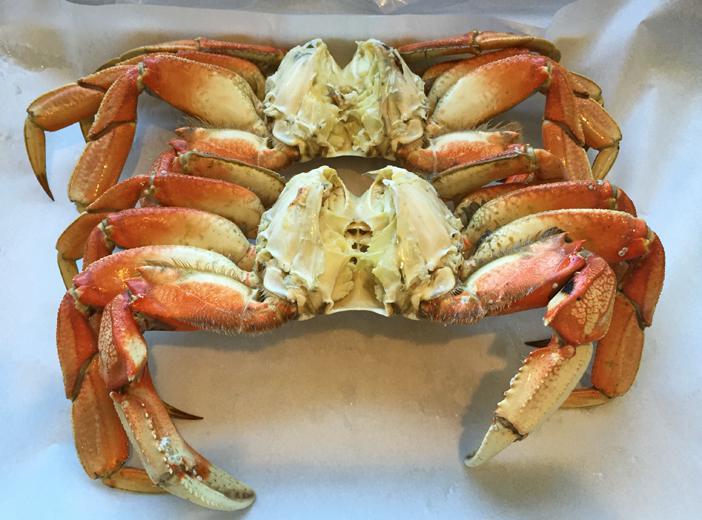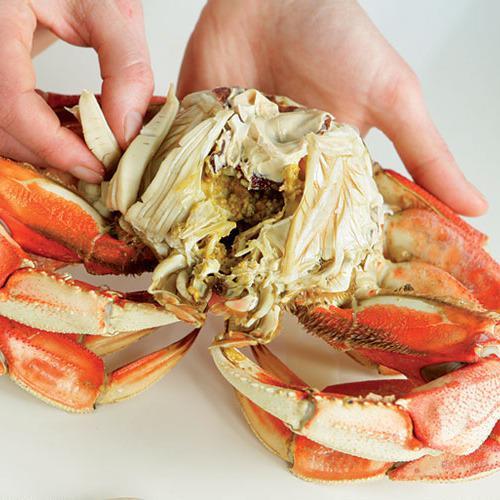The first image is the image on the left, the second image is the image on the right. For the images displayed, is the sentence "The right image includes at least one hand grasping a crab with its shell removed, while the left image shows a view of a crab with no hands present." factually correct? Answer yes or no. Yes. The first image is the image on the left, the second image is the image on the right. Evaluate the accuracy of this statement regarding the images: "there are three crabs in the image pair". Is it true? Answer yes or no. Yes. 